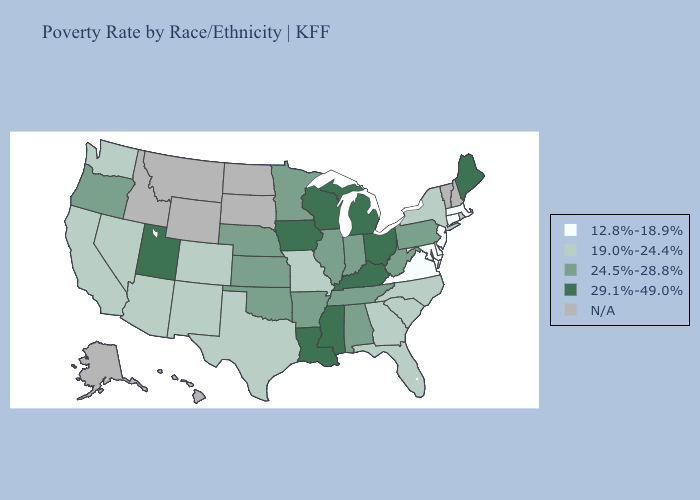Is the legend a continuous bar?
Give a very brief answer. No. Name the states that have a value in the range N/A?
Give a very brief answer. Alaska, Hawaii, Idaho, Montana, New Hampshire, North Dakota, South Dakota, Vermont, Wyoming. Does New Jersey have the highest value in the Northeast?
Short answer required. No. Does Indiana have the highest value in the USA?
Answer briefly. No. What is the highest value in states that border Nebraska?
Write a very short answer. 29.1%-49.0%. Name the states that have a value in the range 12.8%-18.9%?
Concise answer only. Connecticut, Delaware, Maryland, Massachusetts, New Jersey, Virginia. Is the legend a continuous bar?
Be succinct. No. What is the value of Vermont?
Concise answer only. N/A. Which states have the highest value in the USA?
Keep it brief. Iowa, Kentucky, Louisiana, Maine, Michigan, Mississippi, Ohio, Utah, Wisconsin. Does Pennsylvania have the highest value in the Northeast?
Answer briefly. No. Does the map have missing data?
Write a very short answer. Yes. Name the states that have a value in the range 29.1%-49.0%?
Short answer required. Iowa, Kentucky, Louisiana, Maine, Michigan, Mississippi, Ohio, Utah, Wisconsin. What is the value of Washington?
Keep it brief. 19.0%-24.4%. What is the value of Nebraska?
Write a very short answer. 24.5%-28.8%. Does Mississippi have the highest value in the USA?
Be succinct. Yes. 